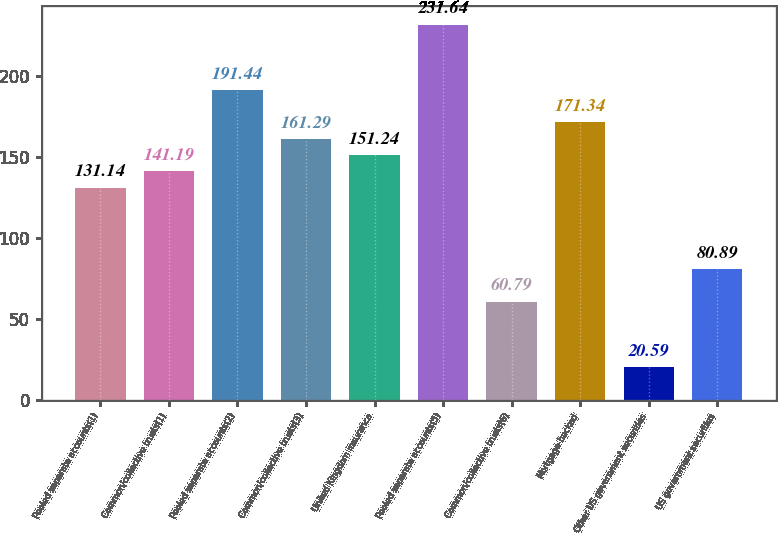Convert chart. <chart><loc_0><loc_0><loc_500><loc_500><bar_chart><fcel>Pooled separate accounts(1)<fcel>Common/collective trusts(1)<fcel>Pooled separate accounts(2)<fcel>Common/collective trusts(3)<fcel>United Kingdom insurance<fcel>Pooled separate accounts(5)<fcel>Common/collective trusts(6)<fcel>Mortgage-backed<fcel>Other US government securities<fcel>US government securities<nl><fcel>131.14<fcel>141.19<fcel>191.44<fcel>161.29<fcel>151.24<fcel>231.64<fcel>60.79<fcel>171.34<fcel>20.59<fcel>80.89<nl></chart> 